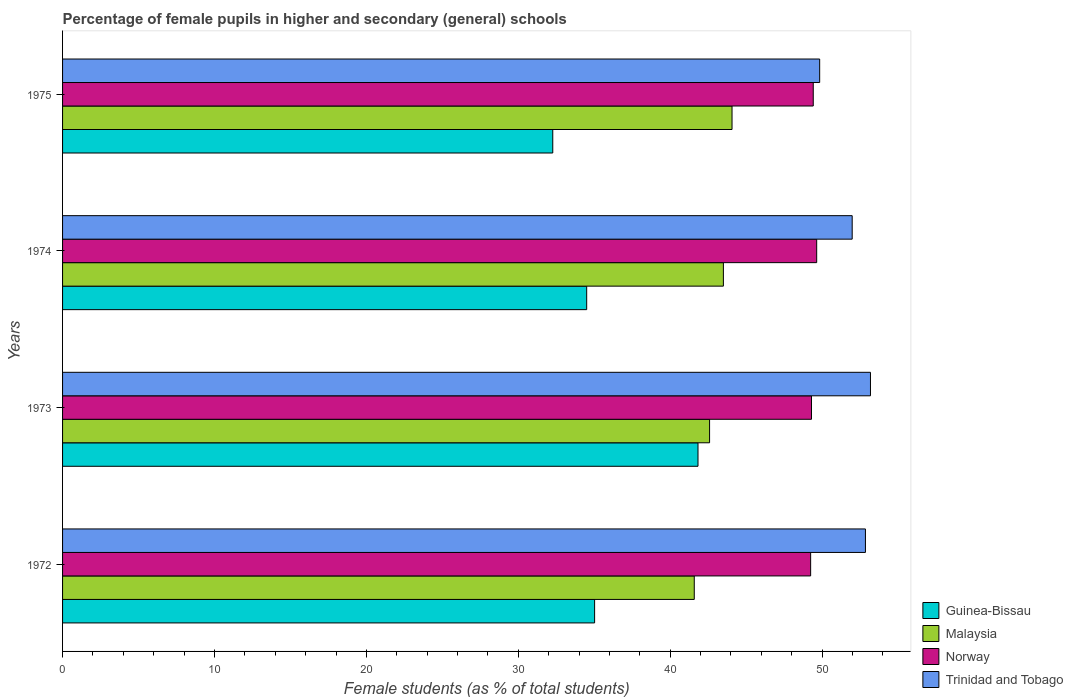How many groups of bars are there?
Provide a short and direct response. 4. How many bars are there on the 1st tick from the top?
Ensure brevity in your answer.  4. How many bars are there on the 1st tick from the bottom?
Provide a short and direct response. 4. What is the label of the 2nd group of bars from the top?
Offer a very short reply. 1974. What is the percentage of female pupils in higher and secondary schools in Trinidad and Tobago in 1972?
Provide a succinct answer. 52.85. Across all years, what is the maximum percentage of female pupils in higher and secondary schools in Malaysia?
Provide a short and direct response. 44.07. Across all years, what is the minimum percentage of female pupils in higher and secondary schools in Malaysia?
Your answer should be very brief. 41.58. In which year was the percentage of female pupils in higher and secondary schools in Guinea-Bissau maximum?
Offer a very short reply. 1973. What is the total percentage of female pupils in higher and secondary schools in Norway in the graph?
Offer a very short reply. 197.6. What is the difference between the percentage of female pupils in higher and secondary schools in Guinea-Bissau in 1974 and that in 1975?
Your answer should be very brief. 2.23. What is the difference between the percentage of female pupils in higher and secondary schools in Trinidad and Tobago in 1973 and the percentage of female pupils in higher and secondary schools in Guinea-Bissau in 1974?
Your answer should be compact. 18.68. What is the average percentage of female pupils in higher and secondary schools in Norway per year?
Make the answer very short. 49.4. In the year 1974, what is the difference between the percentage of female pupils in higher and secondary schools in Malaysia and percentage of female pupils in higher and secondary schools in Trinidad and Tobago?
Your answer should be very brief. -8.48. What is the ratio of the percentage of female pupils in higher and secondary schools in Malaysia in 1972 to that in 1973?
Your answer should be very brief. 0.98. Is the percentage of female pupils in higher and secondary schools in Trinidad and Tobago in 1974 less than that in 1975?
Offer a very short reply. No. What is the difference between the highest and the second highest percentage of female pupils in higher and secondary schools in Malaysia?
Your response must be concise. 0.57. What is the difference between the highest and the lowest percentage of female pupils in higher and secondary schools in Trinidad and Tobago?
Keep it short and to the point. 3.34. Is it the case that in every year, the sum of the percentage of female pupils in higher and secondary schools in Malaysia and percentage of female pupils in higher and secondary schools in Norway is greater than the sum of percentage of female pupils in higher and secondary schools in Trinidad and Tobago and percentage of female pupils in higher and secondary schools in Guinea-Bissau?
Offer a terse response. No. What does the 3rd bar from the top in 1974 represents?
Your answer should be very brief. Malaysia. What does the 4th bar from the bottom in 1975 represents?
Give a very brief answer. Trinidad and Tobago. Is it the case that in every year, the sum of the percentage of female pupils in higher and secondary schools in Guinea-Bissau and percentage of female pupils in higher and secondary schools in Trinidad and Tobago is greater than the percentage of female pupils in higher and secondary schools in Norway?
Provide a succinct answer. Yes. What is the difference between two consecutive major ticks on the X-axis?
Provide a succinct answer. 10. Does the graph contain grids?
Make the answer very short. No. Where does the legend appear in the graph?
Ensure brevity in your answer.  Bottom right. How many legend labels are there?
Give a very brief answer. 4. What is the title of the graph?
Make the answer very short. Percentage of female pupils in higher and secondary (general) schools. What is the label or title of the X-axis?
Offer a terse response. Female students (as % of total students). What is the Female students (as % of total students) in Guinea-Bissau in 1972?
Offer a terse response. 35.02. What is the Female students (as % of total students) of Malaysia in 1972?
Your answer should be very brief. 41.58. What is the Female students (as % of total students) of Norway in 1972?
Keep it short and to the point. 49.24. What is the Female students (as % of total students) of Trinidad and Tobago in 1972?
Offer a very short reply. 52.85. What is the Female students (as % of total students) in Guinea-Bissau in 1973?
Make the answer very short. 41.83. What is the Female students (as % of total students) of Malaysia in 1973?
Provide a succinct answer. 42.59. What is the Female students (as % of total students) of Norway in 1973?
Ensure brevity in your answer.  49.3. What is the Female students (as % of total students) in Trinidad and Tobago in 1973?
Provide a succinct answer. 53.18. What is the Female students (as % of total students) of Guinea-Bissau in 1974?
Offer a terse response. 34.5. What is the Female students (as % of total students) in Malaysia in 1974?
Offer a very short reply. 43.5. What is the Female students (as % of total students) of Norway in 1974?
Make the answer very short. 49.64. What is the Female students (as % of total students) in Trinidad and Tobago in 1974?
Provide a succinct answer. 51.98. What is the Female students (as % of total students) in Guinea-Bissau in 1975?
Offer a very short reply. 32.27. What is the Female students (as % of total students) in Malaysia in 1975?
Offer a very short reply. 44.07. What is the Female students (as % of total students) of Norway in 1975?
Offer a terse response. 49.42. What is the Female students (as % of total students) of Trinidad and Tobago in 1975?
Ensure brevity in your answer.  49.84. Across all years, what is the maximum Female students (as % of total students) in Guinea-Bissau?
Your response must be concise. 41.83. Across all years, what is the maximum Female students (as % of total students) in Malaysia?
Offer a very short reply. 44.07. Across all years, what is the maximum Female students (as % of total students) of Norway?
Your response must be concise. 49.64. Across all years, what is the maximum Female students (as % of total students) of Trinidad and Tobago?
Provide a succinct answer. 53.18. Across all years, what is the minimum Female students (as % of total students) of Guinea-Bissau?
Your answer should be very brief. 32.27. Across all years, what is the minimum Female students (as % of total students) in Malaysia?
Keep it short and to the point. 41.58. Across all years, what is the minimum Female students (as % of total students) of Norway?
Your answer should be very brief. 49.24. Across all years, what is the minimum Female students (as % of total students) in Trinidad and Tobago?
Provide a short and direct response. 49.84. What is the total Female students (as % of total students) of Guinea-Bissau in the graph?
Give a very brief answer. 143.62. What is the total Female students (as % of total students) of Malaysia in the graph?
Provide a short and direct response. 171.74. What is the total Female students (as % of total students) of Norway in the graph?
Keep it short and to the point. 197.6. What is the total Female students (as % of total students) in Trinidad and Tobago in the graph?
Make the answer very short. 207.85. What is the difference between the Female students (as % of total students) in Guinea-Bissau in 1972 and that in 1973?
Provide a short and direct response. -6.81. What is the difference between the Female students (as % of total students) of Malaysia in 1972 and that in 1973?
Make the answer very short. -1.01. What is the difference between the Female students (as % of total students) of Norway in 1972 and that in 1973?
Your response must be concise. -0.06. What is the difference between the Female students (as % of total students) in Trinidad and Tobago in 1972 and that in 1973?
Ensure brevity in your answer.  -0.33. What is the difference between the Female students (as % of total students) in Guinea-Bissau in 1972 and that in 1974?
Provide a succinct answer. 0.52. What is the difference between the Female students (as % of total students) of Malaysia in 1972 and that in 1974?
Your answer should be very brief. -1.92. What is the difference between the Female students (as % of total students) of Norway in 1972 and that in 1974?
Give a very brief answer. -0.4. What is the difference between the Female students (as % of total students) of Trinidad and Tobago in 1972 and that in 1974?
Provide a succinct answer. 0.87. What is the difference between the Female students (as % of total students) in Guinea-Bissau in 1972 and that in 1975?
Offer a terse response. 2.75. What is the difference between the Female students (as % of total students) in Malaysia in 1972 and that in 1975?
Your answer should be very brief. -2.49. What is the difference between the Female students (as % of total students) in Norway in 1972 and that in 1975?
Make the answer very short. -0.17. What is the difference between the Female students (as % of total students) of Trinidad and Tobago in 1972 and that in 1975?
Provide a succinct answer. 3.01. What is the difference between the Female students (as % of total students) of Guinea-Bissau in 1973 and that in 1974?
Keep it short and to the point. 7.33. What is the difference between the Female students (as % of total students) in Malaysia in 1973 and that in 1974?
Keep it short and to the point. -0.91. What is the difference between the Female students (as % of total students) in Norway in 1973 and that in 1974?
Ensure brevity in your answer.  -0.34. What is the difference between the Female students (as % of total students) in Trinidad and Tobago in 1973 and that in 1974?
Offer a terse response. 1.2. What is the difference between the Female students (as % of total students) in Guinea-Bissau in 1973 and that in 1975?
Keep it short and to the point. 9.56. What is the difference between the Female students (as % of total students) in Malaysia in 1973 and that in 1975?
Provide a succinct answer. -1.48. What is the difference between the Female students (as % of total students) of Norway in 1973 and that in 1975?
Provide a short and direct response. -0.12. What is the difference between the Female students (as % of total students) of Trinidad and Tobago in 1973 and that in 1975?
Ensure brevity in your answer.  3.34. What is the difference between the Female students (as % of total students) in Guinea-Bissau in 1974 and that in 1975?
Your answer should be compact. 2.23. What is the difference between the Female students (as % of total students) in Malaysia in 1974 and that in 1975?
Offer a very short reply. -0.57. What is the difference between the Female students (as % of total students) in Norway in 1974 and that in 1975?
Offer a terse response. 0.23. What is the difference between the Female students (as % of total students) of Trinidad and Tobago in 1974 and that in 1975?
Keep it short and to the point. 2.14. What is the difference between the Female students (as % of total students) of Guinea-Bissau in 1972 and the Female students (as % of total students) of Malaysia in 1973?
Make the answer very short. -7.57. What is the difference between the Female students (as % of total students) of Guinea-Bissau in 1972 and the Female students (as % of total students) of Norway in 1973?
Offer a very short reply. -14.28. What is the difference between the Female students (as % of total students) in Guinea-Bissau in 1972 and the Female students (as % of total students) in Trinidad and Tobago in 1973?
Your response must be concise. -18.16. What is the difference between the Female students (as % of total students) in Malaysia in 1972 and the Female students (as % of total students) in Norway in 1973?
Keep it short and to the point. -7.72. What is the difference between the Female students (as % of total students) of Malaysia in 1972 and the Female students (as % of total students) of Trinidad and Tobago in 1973?
Make the answer very short. -11.6. What is the difference between the Female students (as % of total students) in Norway in 1972 and the Female students (as % of total students) in Trinidad and Tobago in 1973?
Offer a terse response. -3.94. What is the difference between the Female students (as % of total students) in Guinea-Bissau in 1972 and the Female students (as % of total students) in Malaysia in 1974?
Your answer should be very brief. -8.48. What is the difference between the Female students (as % of total students) in Guinea-Bissau in 1972 and the Female students (as % of total students) in Norway in 1974?
Provide a short and direct response. -14.62. What is the difference between the Female students (as % of total students) of Guinea-Bissau in 1972 and the Female students (as % of total students) of Trinidad and Tobago in 1974?
Ensure brevity in your answer.  -16.96. What is the difference between the Female students (as % of total students) in Malaysia in 1972 and the Female students (as % of total students) in Norway in 1974?
Your response must be concise. -8.06. What is the difference between the Female students (as % of total students) in Malaysia in 1972 and the Female students (as % of total students) in Trinidad and Tobago in 1974?
Your answer should be compact. -10.4. What is the difference between the Female students (as % of total students) in Norway in 1972 and the Female students (as % of total students) in Trinidad and Tobago in 1974?
Offer a terse response. -2.74. What is the difference between the Female students (as % of total students) in Guinea-Bissau in 1972 and the Female students (as % of total students) in Malaysia in 1975?
Offer a terse response. -9.05. What is the difference between the Female students (as % of total students) in Guinea-Bissau in 1972 and the Female students (as % of total students) in Norway in 1975?
Your answer should be compact. -14.39. What is the difference between the Female students (as % of total students) in Guinea-Bissau in 1972 and the Female students (as % of total students) in Trinidad and Tobago in 1975?
Give a very brief answer. -14.81. What is the difference between the Female students (as % of total students) of Malaysia in 1972 and the Female students (as % of total students) of Norway in 1975?
Provide a short and direct response. -7.83. What is the difference between the Female students (as % of total students) in Malaysia in 1972 and the Female students (as % of total students) in Trinidad and Tobago in 1975?
Offer a terse response. -8.26. What is the difference between the Female students (as % of total students) in Norway in 1972 and the Female students (as % of total students) in Trinidad and Tobago in 1975?
Provide a succinct answer. -0.59. What is the difference between the Female students (as % of total students) of Guinea-Bissau in 1973 and the Female students (as % of total students) of Malaysia in 1974?
Make the answer very short. -1.67. What is the difference between the Female students (as % of total students) of Guinea-Bissau in 1973 and the Female students (as % of total students) of Norway in 1974?
Keep it short and to the point. -7.81. What is the difference between the Female students (as % of total students) in Guinea-Bissau in 1973 and the Female students (as % of total students) in Trinidad and Tobago in 1974?
Ensure brevity in your answer.  -10.15. What is the difference between the Female students (as % of total students) in Malaysia in 1973 and the Female students (as % of total students) in Norway in 1974?
Your answer should be compact. -7.05. What is the difference between the Female students (as % of total students) of Malaysia in 1973 and the Female students (as % of total students) of Trinidad and Tobago in 1974?
Ensure brevity in your answer.  -9.39. What is the difference between the Female students (as % of total students) of Norway in 1973 and the Female students (as % of total students) of Trinidad and Tobago in 1974?
Your answer should be very brief. -2.68. What is the difference between the Female students (as % of total students) in Guinea-Bissau in 1973 and the Female students (as % of total students) in Malaysia in 1975?
Provide a succinct answer. -2.24. What is the difference between the Female students (as % of total students) of Guinea-Bissau in 1973 and the Female students (as % of total students) of Norway in 1975?
Your response must be concise. -7.59. What is the difference between the Female students (as % of total students) of Guinea-Bissau in 1973 and the Female students (as % of total students) of Trinidad and Tobago in 1975?
Ensure brevity in your answer.  -8.01. What is the difference between the Female students (as % of total students) in Malaysia in 1973 and the Female students (as % of total students) in Norway in 1975?
Ensure brevity in your answer.  -6.82. What is the difference between the Female students (as % of total students) in Malaysia in 1973 and the Female students (as % of total students) in Trinidad and Tobago in 1975?
Make the answer very short. -7.25. What is the difference between the Female students (as % of total students) of Norway in 1973 and the Female students (as % of total students) of Trinidad and Tobago in 1975?
Offer a terse response. -0.54. What is the difference between the Female students (as % of total students) of Guinea-Bissau in 1974 and the Female students (as % of total students) of Malaysia in 1975?
Keep it short and to the point. -9.57. What is the difference between the Female students (as % of total students) of Guinea-Bissau in 1974 and the Female students (as % of total students) of Norway in 1975?
Offer a very short reply. -14.91. What is the difference between the Female students (as % of total students) in Guinea-Bissau in 1974 and the Female students (as % of total students) in Trinidad and Tobago in 1975?
Your answer should be compact. -15.34. What is the difference between the Female students (as % of total students) in Malaysia in 1974 and the Female students (as % of total students) in Norway in 1975?
Your answer should be compact. -5.92. What is the difference between the Female students (as % of total students) in Malaysia in 1974 and the Female students (as % of total students) in Trinidad and Tobago in 1975?
Offer a terse response. -6.34. What is the difference between the Female students (as % of total students) of Norway in 1974 and the Female students (as % of total students) of Trinidad and Tobago in 1975?
Your answer should be compact. -0.2. What is the average Female students (as % of total students) in Guinea-Bissau per year?
Ensure brevity in your answer.  35.91. What is the average Female students (as % of total students) in Malaysia per year?
Your answer should be very brief. 42.94. What is the average Female students (as % of total students) in Norway per year?
Your answer should be compact. 49.4. What is the average Female students (as % of total students) of Trinidad and Tobago per year?
Ensure brevity in your answer.  51.96. In the year 1972, what is the difference between the Female students (as % of total students) in Guinea-Bissau and Female students (as % of total students) in Malaysia?
Give a very brief answer. -6.56. In the year 1972, what is the difference between the Female students (as % of total students) of Guinea-Bissau and Female students (as % of total students) of Norway?
Give a very brief answer. -14.22. In the year 1972, what is the difference between the Female students (as % of total students) of Guinea-Bissau and Female students (as % of total students) of Trinidad and Tobago?
Provide a succinct answer. -17.83. In the year 1972, what is the difference between the Female students (as % of total students) of Malaysia and Female students (as % of total students) of Norway?
Your answer should be compact. -7.66. In the year 1972, what is the difference between the Female students (as % of total students) of Malaysia and Female students (as % of total students) of Trinidad and Tobago?
Offer a very short reply. -11.27. In the year 1972, what is the difference between the Female students (as % of total students) in Norway and Female students (as % of total students) in Trinidad and Tobago?
Make the answer very short. -3.61. In the year 1973, what is the difference between the Female students (as % of total students) in Guinea-Bissau and Female students (as % of total students) in Malaysia?
Offer a terse response. -0.76. In the year 1973, what is the difference between the Female students (as % of total students) of Guinea-Bissau and Female students (as % of total students) of Norway?
Keep it short and to the point. -7.47. In the year 1973, what is the difference between the Female students (as % of total students) in Guinea-Bissau and Female students (as % of total students) in Trinidad and Tobago?
Your response must be concise. -11.35. In the year 1973, what is the difference between the Female students (as % of total students) of Malaysia and Female students (as % of total students) of Norway?
Provide a succinct answer. -6.71. In the year 1973, what is the difference between the Female students (as % of total students) in Malaysia and Female students (as % of total students) in Trinidad and Tobago?
Offer a terse response. -10.59. In the year 1973, what is the difference between the Female students (as % of total students) of Norway and Female students (as % of total students) of Trinidad and Tobago?
Ensure brevity in your answer.  -3.88. In the year 1974, what is the difference between the Female students (as % of total students) of Guinea-Bissau and Female students (as % of total students) of Malaysia?
Make the answer very short. -9. In the year 1974, what is the difference between the Female students (as % of total students) of Guinea-Bissau and Female students (as % of total students) of Norway?
Your answer should be very brief. -15.14. In the year 1974, what is the difference between the Female students (as % of total students) of Guinea-Bissau and Female students (as % of total students) of Trinidad and Tobago?
Ensure brevity in your answer.  -17.48. In the year 1974, what is the difference between the Female students (as % of total students) in Malaysia and Female students (as % of total students) in Norway?
Your response must be concise. -6.14. In the year 1974, what is the difference between the Female students (as % of total students) of Malaysia and Female students (as % of total students) of Trinidad and Tobago?
Your response must be concise. -8.48. In the year 1974, what is the difference between the Female students (as % of total students) of Norway and Female students (as % of total students) of Trinidad and Tobago?
Your response must be concise. -2.34. In the year 1975, what is the difference between the Female students (as % of total students) of Guinea-Bissau and Female students (as % of total students) of Malaysia?
Make the answer very short. -11.8. In the year 1975, what is the difference between the Female students (as % of total students) in Guinea-Bissau and Female students (as % of total students) in Norway?
Your answer should be very brief. -17.15. In the year 1975, what is the difference between the Female students (as % of total students) of Guinea-Bissau and Female students (as % of total students) of Trinidad and Tobago?
Give a very brief answer. -17.57. In the year 1975, what is the difference between the Female students (as % of total students) of Malaysia and Female students (as % of total students) of Norway?
Give a very brief answer. -5.35. In the year 1975, what is the difference between the Female students (as % of total students) of Malaysia and Female students (as % of total students) of Trinidad and Tobago?
Offer a terse response. -5.77. In the year 1975, what is the difference between the Female students (as % of total students) of Norway and Female students (as % of total students) of Trinidad and Tobago?
Your response must be concise. -0.42. What is the ratio of the Female students (as % of total students) of Guinea-Bissau in 1972 to that in 1973?
Provide a succinct answer. 0.84. What is the ratio of the Female students (as % of total students) of Malaysia in 1972 to that in 1973?
Your response must be concise. 0.98. What is the ratio of the Female students (as % of total students) of Trinidad and Tobago in 1972 to that in 1973?
Your response must be concise. 0.99. What is the ratio of the Female students (as % of total students) in Guinea-Bissau in 1972 to that in 1974?
Your response must be concise. 1.02. What is the ratio of the Female students (as % of total students) of Malaysia in 1972 to that in 1974?
Give a very brief answer. 0.96. What is the ratio of the Female students (as % of total students) in Trinidad and Tobago in 1972 to that in 1974?
Ensure brevity in your answer.  1.02. What is the ratio of the Female students (as % of total students) of Guinea-Bissau in 1972 to that in 1975?
Your answer should be compact. 1.09. What is the ratio of the Female students (as % of total students) of Malaysia in 1972 to that in 1975?
Make the answer very short. 0.94. What is the ratio of the Female students (as % of total students) in Trinidad and Tobago in 1972 to that in 1975?
Your response must be concise. 1.06. What is the ratio of the Female students (as % of total students) of Guinea-Bissau in 1973 to that in 1974?
Your answer should be compact. 1.21. What is the ratio of the Female students (as % of total students) of Malaysia in 1973 to that in 1974?
Offer a terse response. 0.98. What is the ratio of the Female students (as % of total students) of Trinidad and Tobago in 1973 to that in 1974?
Offer a very short reply. 1.02. What is the ratio of the Female students (as % of total students) of Guinea-Bissau in 1973 to that in 1975?
Make the answer very short. 1.3. What is the ratio of the Female students (as % of total students) of Malaysia in 1973 to that in 1975?
Make the answer very short. 0.97. What is the ratio of the Female students (as % of total students) in Trinidad and Tobago in 1973 to that in 1975?
Make the answer very short. 1.07. What is the ratio of the Female students (as % of total students) of Guinea-Bissau in 1974 to that in 1975?
Give a very brief answer. 1.07. What is the ratio of the Female students (as % of total students) in Malaysia in 1974 to that in 1975?
Provide a short and direct response. 0.99. What is the ratio of the Female students (as % of total students) in Norway in 1974 to that in 1975?
Provide a short and direct response. 1. What is the ratio of the Female students (as % of total students) of Trinidad and Tobago in 1974 to that in 1975?
Make the answer very short. 1.04. What is the difference between the highest and the second highest Female students (as % of total students) of Guinea-Bissau?
Your answer should be compact. 6.81. What is the difference between the highest and the second highest Female students (as % of total students) in Malaysia?
Your answer should be very brief. 0.57. What is the difference between the highest and the second highest Female students (as % of total students) of Norway?
Provide a short and direct response. 0.23. What is the difference between the highest and the second highest Female students (as % of total students) in Trinidad and Tobago?
Your answer should be very brief. 0.33. What is the difference between the highest and the lowest Female students (as % of total students) of Guinea-Bissau?
Make the answer very short. 9.56. What is the difference between the highest and the lowest Female students (as % of total students) of Malaysia?
Offer a very short reply. 2.49. What is the difference between the highest and the lowest Female students (as % of total students) of Norway?
Your response must be concise. 0.4. What is the difference between the highest and the lowest Female students (as % of total students) of Trinidad and Tobago?
Provide a succinct answer. 3.34. 